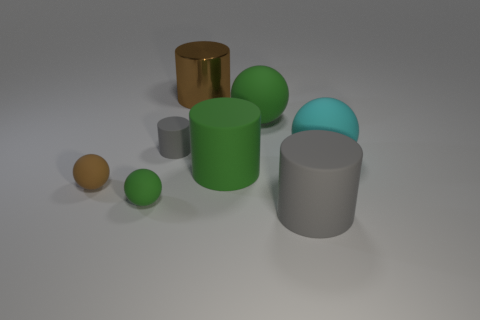Subtract all green cylinders. How many cylinders are left? 3 Subtract all cyan spheres. How many spheres are left? 3 Subtract 3 cylinders. How many cylinders are left? 1 Add 2 big green matte balls. How many objects exist? 10 Subtract all red cylinders. Subtract all cyan cubes. How many cylinders are left? 4 Subtract all blue cylinders. How many purple balls are left? 0 Subtract all tiny blue matte blocks. Subtract all green rubber cylinders. How many objects are left? 7 Add 4 big things. How many big things are left? 9 Add 6 big yellow matte cylinders. How many big yellow matte cylinders exist? 6 Subtract 0 yellow cylinders. How many objects are left? 8 